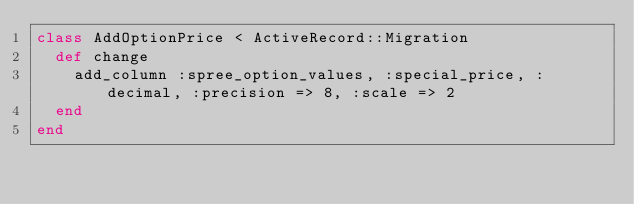<code> <loc_0><loc_0><loc_500><loc_500><_Ruby_>class AddOptionPrice < ActiveRecord::Migration
  def change
    add_column :spree_option_values, :special_price, :decimal, :precision => 8, :scale => 2
  end
end
</code> 